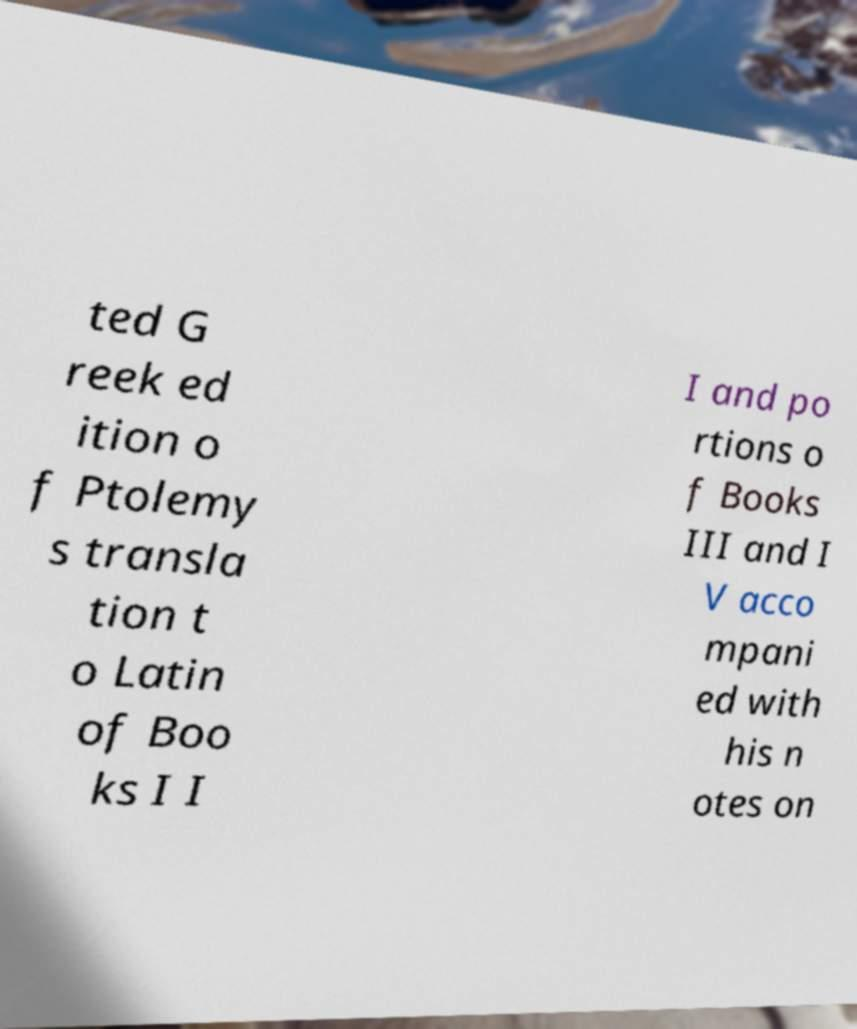I need the written content from this picture converted into text. Can you do that? ted G reek ed ition o f Ptolemy s transla tion t o Latin of Boo ks I I I and po rtions o f Books III and I V acco mpani ed with his n otes on 